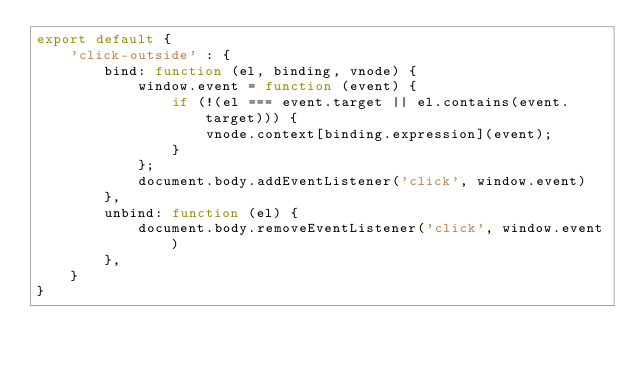Convert code to text. <code><loc_0><loc_0><loc_500><loc_500><_JavaScript_>export default {
    'click-outside' : {
        bind: function (el, binding, vnode) {
            window.event = function (event) {
                if (!(el === event.target || el.contains(event.target))) {
                    vnode.context[binding.expression](event);
                }
            };
            document.body.addEventListener('click', window.event)
        },
        unbind: function (el) {
            document.body.removeEventListener('click', window.event)
        },
    }
}
</code> 